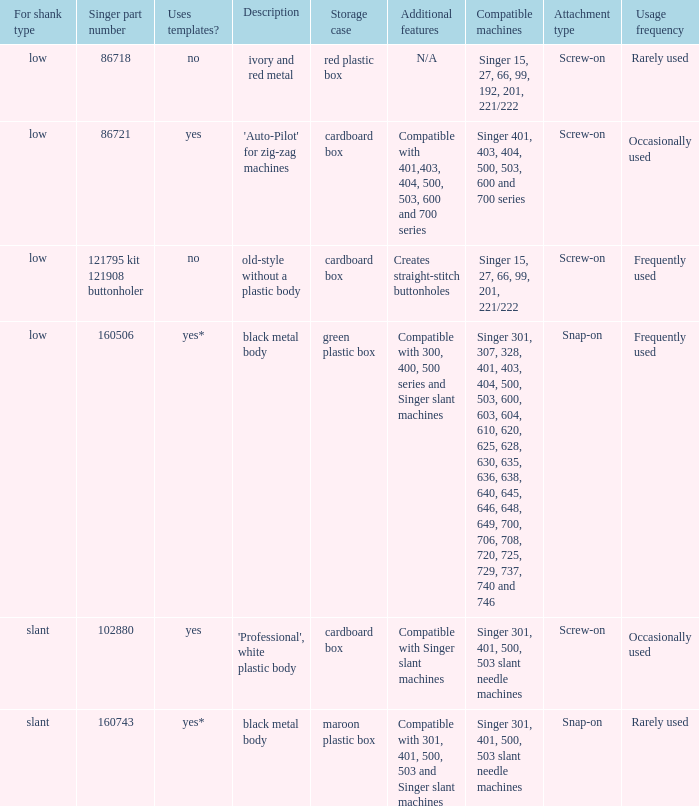What are all the different descriptions for the buttonholer with cardboard box for storage and a low shank type? 'Auto-Pilot' for zig-zag machines, old-style without a plastic body. 